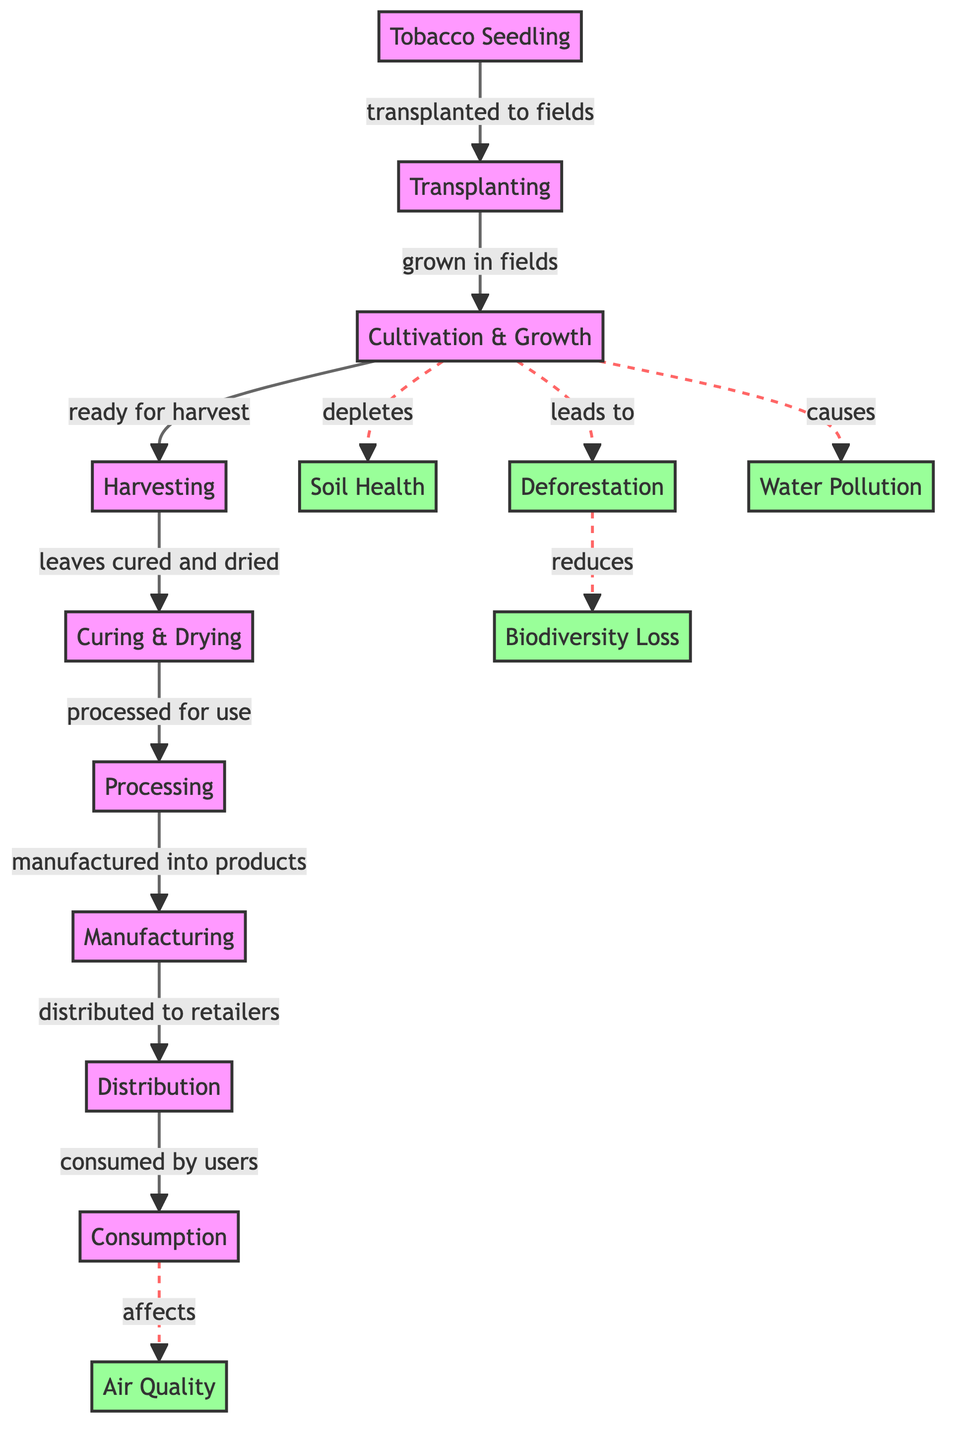What is the first stage of the tobacco lifecycle? The diagram starts with the "Tobacco Seedling" as the first stage before proceeding to the transplanting step.
Answer: Tobacco Seedling What process follows transplanting in the tobacco lifecycle? After transplanting, the next stage in the lifecycle is "Cultivation & Growth," showing the sequence from one step to the next.
Answer: Cultivation & Growth How many environmental impacts are listed in the diagram? The diagram lists five specific environmental impacts: Air Quality, Soil Health, Deforestation, Biodiversity Loss, and Water Pollution.
Answer: Five Which stage leads to air quality impacts? The "Consumption" stage is shown to affect air quality, indicating the flow from usage to environmental impact.
Answer: Consumption What is the final product stage in the lifecycle? The last stage of the lifecycle outlined in the diagram is "Consumption," where the products are used by consumers.
Answer: Consumption What is the relationship between cultivation and water pollution? The diagram explicitly indicates that cultivation causes water pollution, showing a direct connection between these two elements.
Answer: Causes How does deforestation affect biodiversity according to the diagram? The diagram details that deforestation reduces biodiversity, establishing a causal relationship from one environmental impact to another.
Answer: Reduces What two environmental impacts are directly linked to cultivation? The cultivation stage directly leads to soil health depletion and causes water pollution, as indicated by the arrows in the diagram.
Answer: Soil Health and Water Pollution What happens after the curing stage in the tobacco lifecycle? Following the curing stage, the tobacco goes through "Processing," which is the next step in the workflow of this lifecycle.
Answer: Processing 